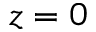<formula> <loc_0><loc_0><loc_500><loc_500>z = 0</formula> 